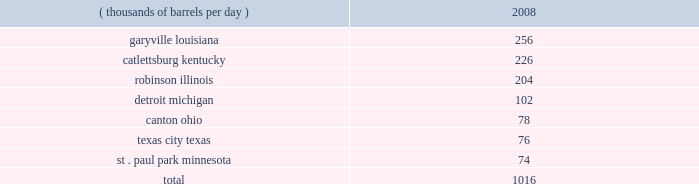Our refineries processed 944 mbpd of crude oil and 207 mbpd of other charge and blend stocks .
The table below sets forth the location and daily crude oil refining capacity of each of our refineries as of december 31 , 2008 .
Crude oil refining capacity ( thousands of barrels per day ) 2008 .
Our refineries include crude oil atmospheric and vacuum distillation , fluid catalytic cracking , catalytic reforming , desulfurization and sulfur recovery units .
The refineries process a wide variety of crude oils and produce numerous refined products , ranging from transportation fuels , such as reformulated gasolines , blend- grade gasolines intended for blending with fuel ethanol and ultra-low sulfur diesel fuel , to heavy fuel oil and asphalt .
Additionally , we manufacture aromatics , cumene , propane , propylene , sulfur and maleic anhydride .
Our refineries are integrated with each other via pipelines , terminals and barges to maximize operating efficiency .
The transportation links that connect our refineries allow the movement of intermediate products between refineries to optimize operations , produce higher margin products and utilize our processing capacity efficiently .
Our garyville , louisiana , refinery is located along the mississippi river in southeastern louisiana .
The garyville refinery processes heavy sour crude oil into products such as gasoline , distillates , sulfur , asphalt , propane , polymer grade propylene , isobutane and coke .
In 2006 , we approved an expansion of our garyville refinery by 180 mbpd to 436 mbpd , with a currently projected cost of $ 3.35 billion ( excluding capitalized interest ) .
Construction commenced in early 2007 and is continuing on schedule .
We estimate that , as of december 31 , 2008 , this project is approximately 75 percent complete .
We expect to complete the expansion in late 2009 .
Our catlettsburg , kentucky , refinery is located in northeastern kentucky on the western bank of the big sandy river , near the confluence with the ohio river .
The catlettsburg refinery processes sweet and sour crude oils into products such as gasoline , asphalt , diesel , jet fuel , petrochemicals , propane , propylene and sulfur .
Our robinson , illinois , refinery is located in the southeastern illinois town of robinson .
The robinson refinery processes sweet and sour crude oils into products such as multiple grades of gasoline , jet fuel , kerosene , diesel fuel , propane , propylene , sulfur and anode-grade coke .
Our detroit , michigan , refinery is located near interstate 75 in southwest detroit .
The detroit refinery processes light sweet and heavy sour crude oils , including canadian crude oils , into products such as gasoline , diesel , asphalt , slurry , propane , chemical grade propylene and sulfur .
In 2007 , we approved a heavy oil upgrading and expansion project at our detroit , michigan , refinery , with a current projected cost of $ 2.2 billion ( excluding capitalized interest ) .
This project will enable the refinery to process additional heavy sour crude oils , including canadian bitumen blends , and will increase its crude oil refining capacity by about 15 percent .
Construction began in the first half of 2008 and is presently expected to be complete in mid-2012 .
Our canton , ohio , refinery is located approximately 60 miles southeast of cleveland , ohio .
The canton refinery processes sweet and sour crude oils into products such as gasoline , diesel fuels , kerosene , propane , sulfur , asphalt , roofing flux , home heating oil and no .
6 industrial fuel oil .
Our texas city , texas , refinery is located on the texas gulf coast approximately 30 miles south of houston , texas .
The refinery processes sweet crude oil into products such as gasoline , propane , chemical grade propylene , slurry , sulfur and aromatics .
Our st .
Paul park , minnesota , refinery is located in st .
Paul park , a suburb of minneapolis-st .
Paul .
The st .
Paul park refinery processes predominantly canadian crude oils into products such as gasoline , diesel , jet fuel , kerosene , asphalt , propane , propylene and sulfur. .
What percentage of crude oil refining capacity is located in robinson illinois? 
Computations: (204 / 1016)
Answer: 0.20079. 